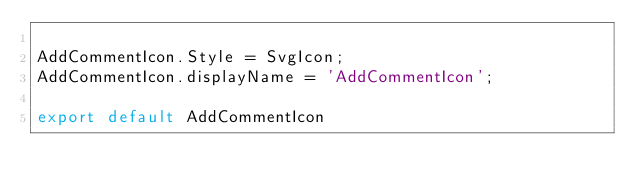<code> <loc_0><loc_0><loc_500><loc_500><_TypeScript_>
AddCommentIcon.Style = SvgIcon;
AddCommentIcon.displayName = 'AddCommentIcon';

export default AddCommentIcon
</code> 